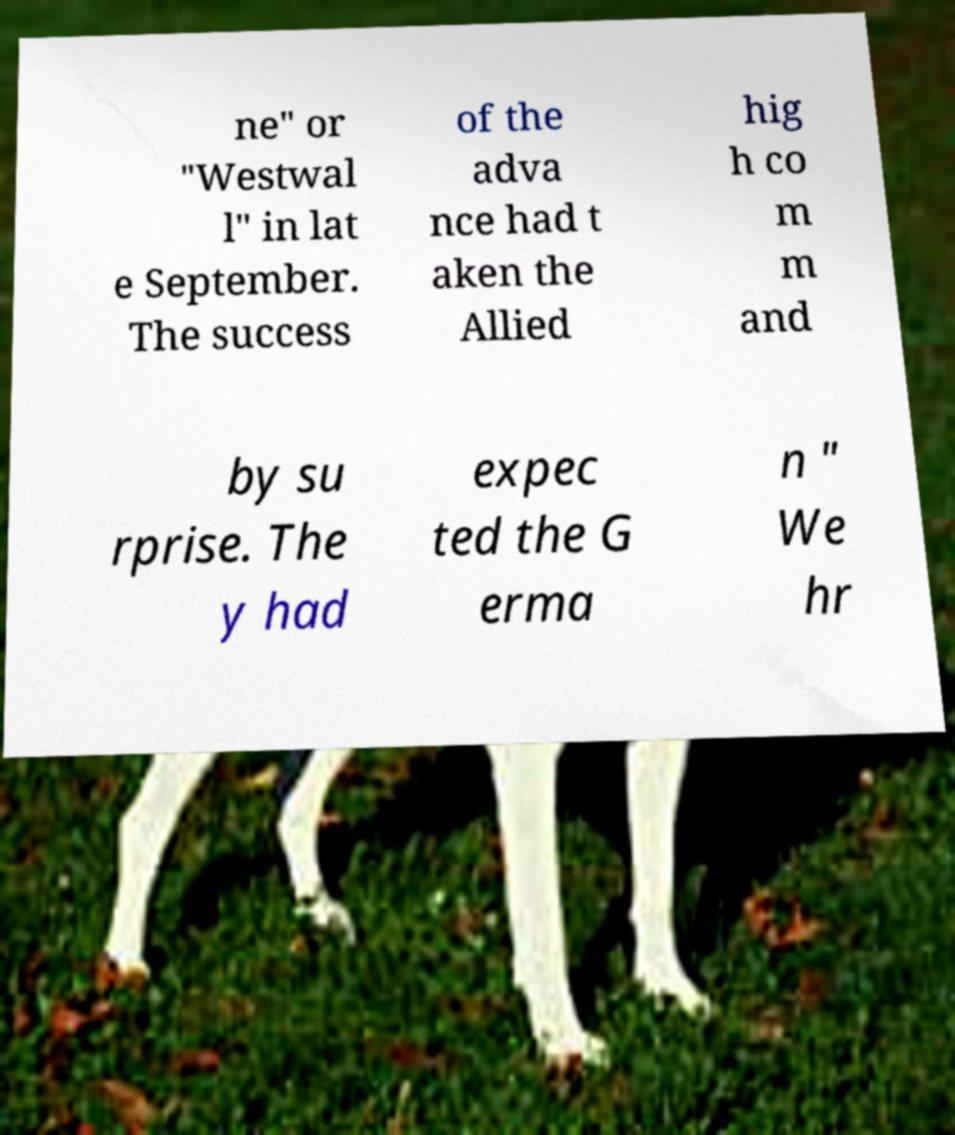Could you extract and type out the text from this image? ne" or "Westwal l" in lat e September. The success of the adva nce had t aken the Allied hig h co m m and by su rprise. The y had expec ted the G erma n " We hr 